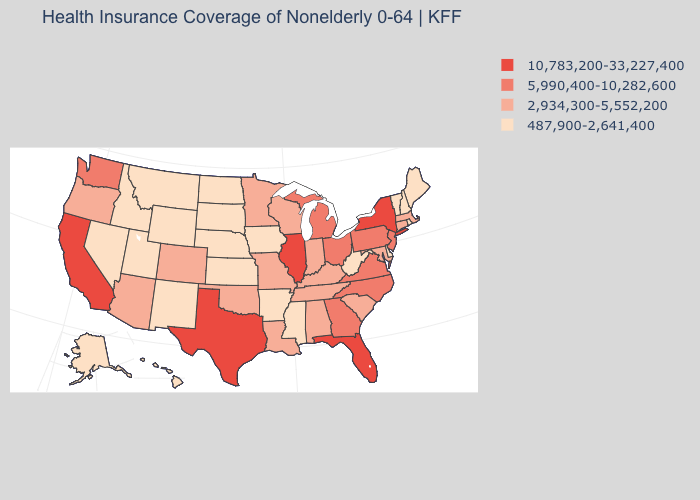Does Rhode Island have the same value as Nebraska?
Keep it brief. Yes. Is the legend a continuous bar?
Write a very short answer. No. Which states have the highest value in the USA?
Answer briefly. California, Florida, Illinois, New York, Texas. Does Pennsylvania have the same value as West Virginia?
Concise answer only. No. What is the value of Washington?
Quick response, please. 5,990,400-10,282,600. Name the states that have a value in the range 10,783,200-33,227,400?
Write a very short answer. California, Florida, Illinois, New York, Texas. Which states have the lowest value in the West?
Quick response, please. Alaska, Hawaii, Idaho, Montana, Nevada, New Mexico, Utah, Wyoming. Name the states that have a value in the range 5,990,400-10,282,600?
Write a very short answer. Georgia, Michigan, New Jersey, North Carolina, Ohio, Pennsylvania, Virginia, Washington. What is the value of Minnesota?
Answer briefly. 2,934,300-5,552,200. What is the value of New Jersey?
Keep it brief. 5,990,400-10,282,600. Among the states that border Pennsylvania , which have the highest value?
Keep it brief. New York. Does Illinois have the lowest value in the MidWest?
Answer briefly. No. Is the legend a continuous bar?
Be succinct. No. What is the highest value in the USA?
Give a very brief answer. 10,783,200-33,227,400. Does the first symbol in the legend represent the smallest category?
Quick response, please. No. 